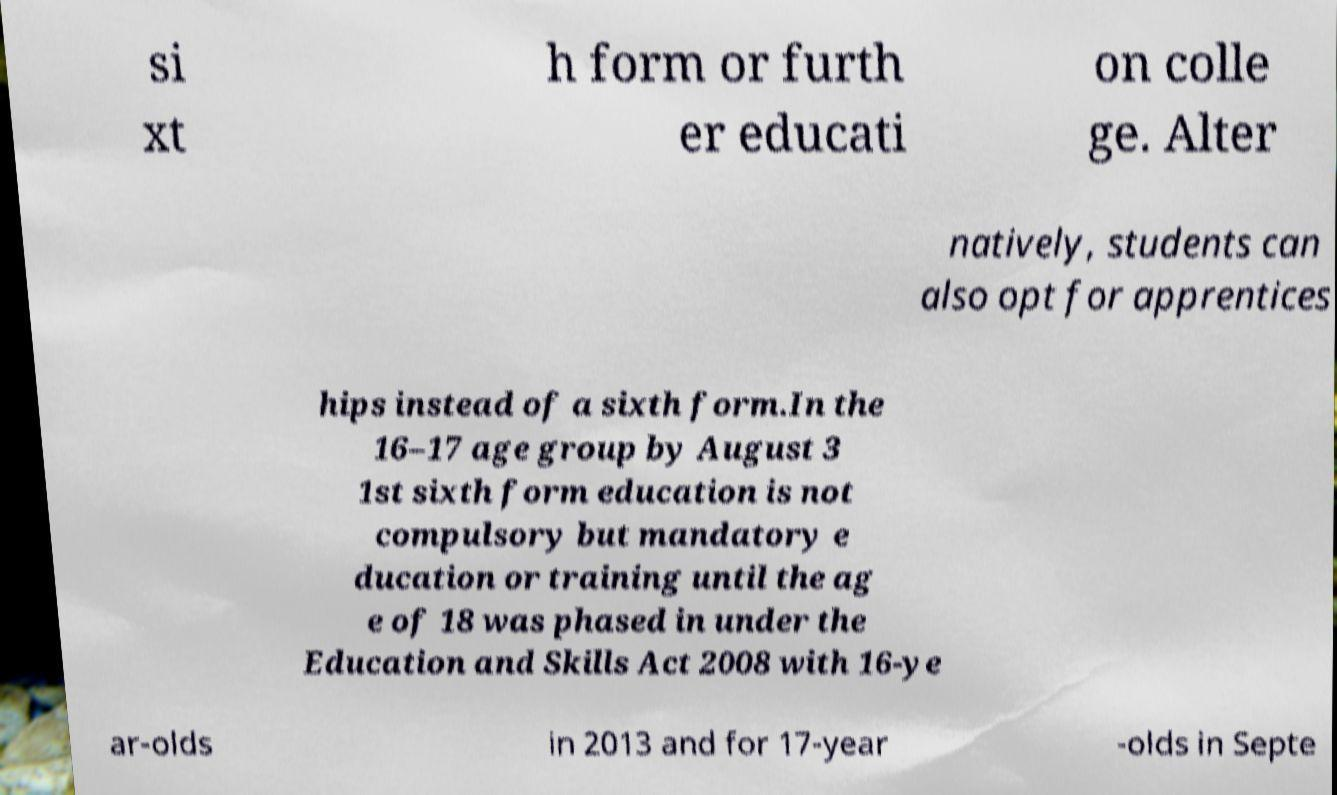Could you assist in decoding the text presented in this image and type it out clearly? si xt h form or furth er educati on colle ge. Alter natively, students can also opt for apprentices hips instead of a sixth form.In the 16–17 age group by August 3 1st sixth form education is not compulsory but mandatory e ducation or training until the ag e of 18 was phased in under the Education and Skills Act 2008 with 16-ye ar-olds in 2013 and for 17-year -olds in Septe 